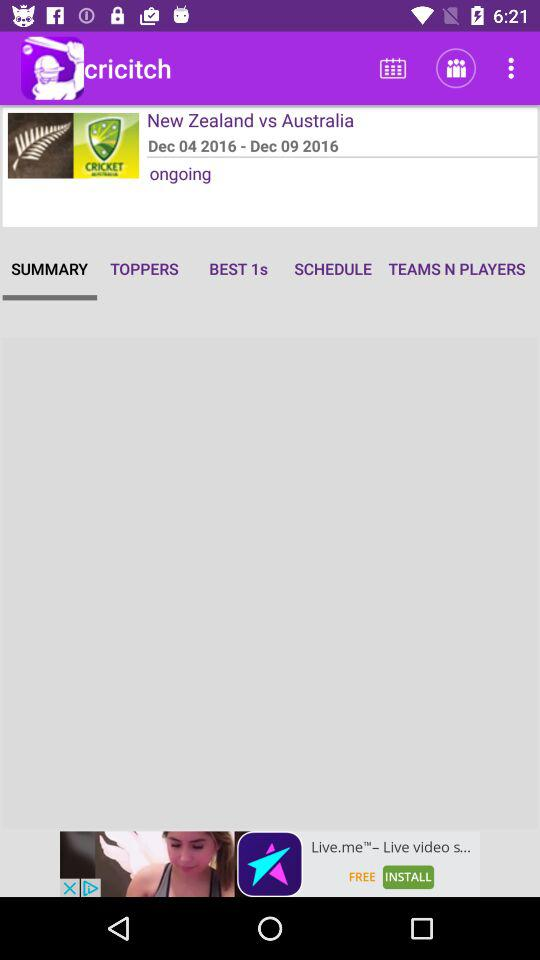What’s the app name? The app name is "cricitch". 